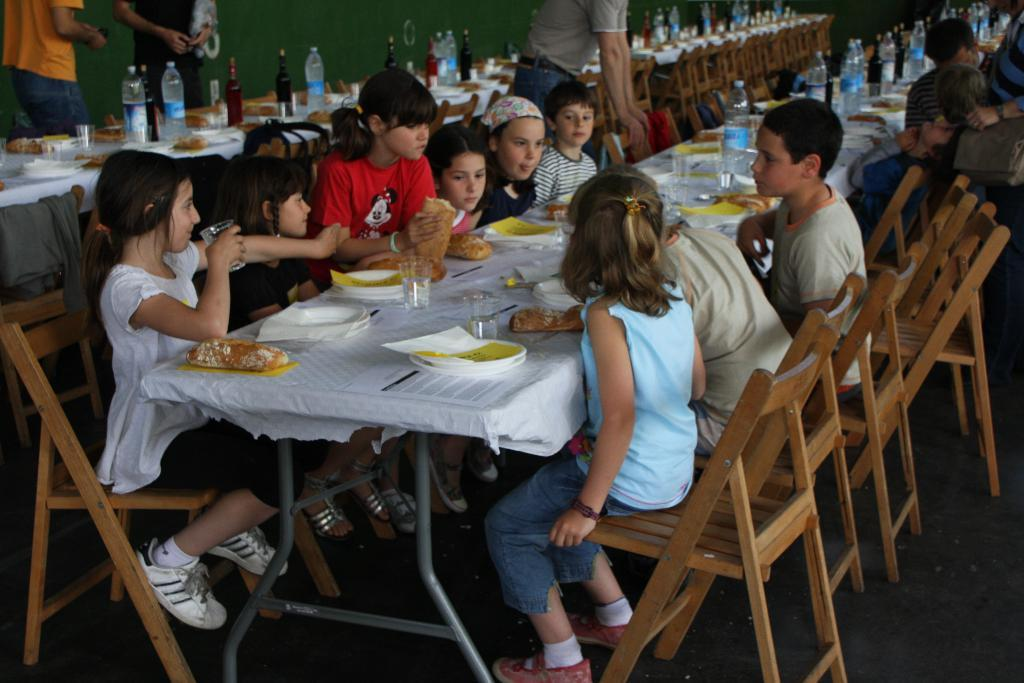How many children are present in the image? There are many children in the image. What are the children doing in the image? The children are sitting on chairs. Is there any furniture in front of the children? Yes, there is a table in front of the children. What type of trains can be seen passing by in the image? There are no trains present in the image; it features many children sitting on chairs with a table in front of them. 